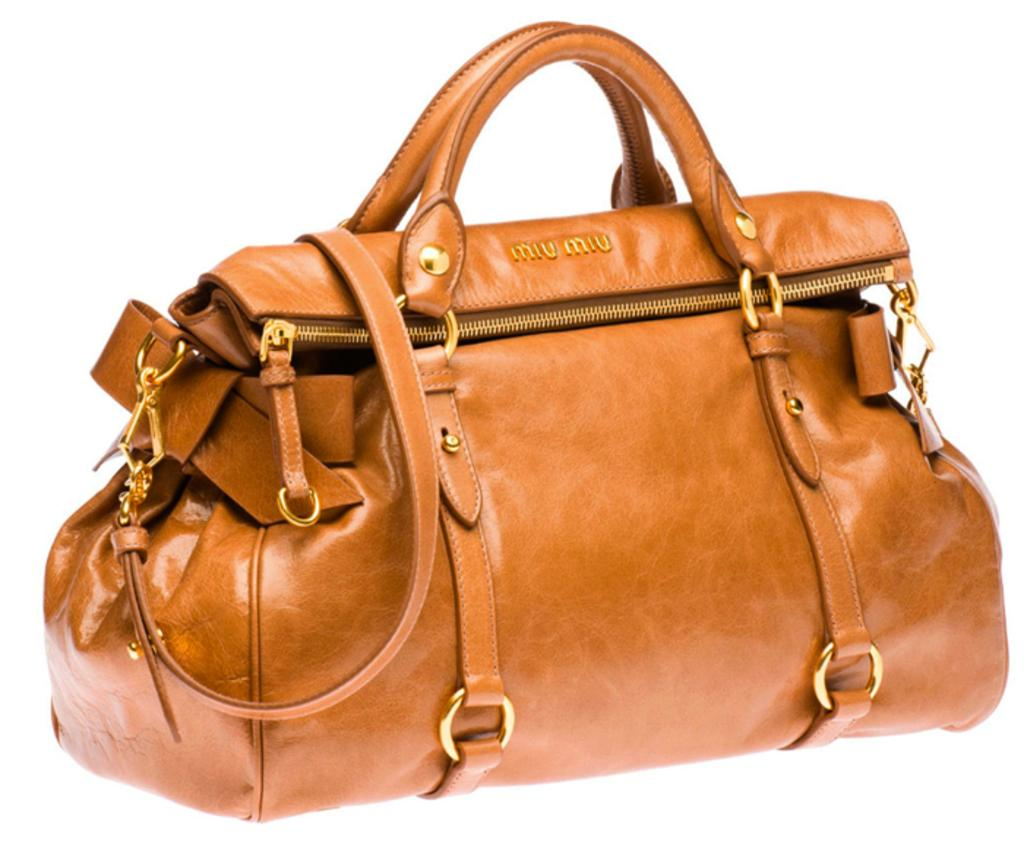What type of bag is shown in the image? The image depicts a brown leather duffle bag. What is the purpose of the bag? The bag is for traveling. What are the features of the bag that help in carrying it? The bag has golden hooks on its sides and a zipper on its sides, which are used for carrying the load. What type of record can be seen playing on the store's sound system in the image? There is no store or record player present in the image; it only shows a brown leather duffle bag. What subject is being taught in the class depicted in the image? There is no class or subject being taught in the image; it only shows a brown leather duffle bag. 